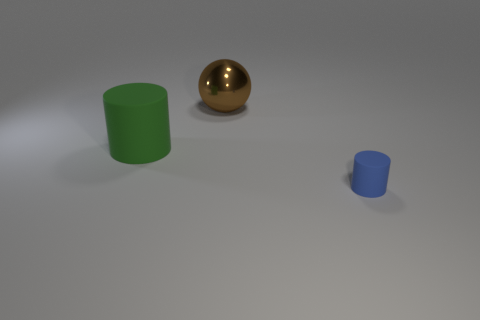There is a cylinder that is in front of the rubber cylinder behind the tiny blue object; what is it made of?
Your answer should be very brief. Rubber. Is the material of the thing that is behind the large rubber thing the same as the small thing?
Your answer should be compact. No. What is the cylinder that is behind the small blue rubber thing made of?
Provide a short and direct response. Rubber. Is there any other thing that has the same size as the blue rubber cylinder?
Offer a terse response. No. There is a blue cylinder; are there any rubber things behind it?
Provide a short and direct response. Yes. What number of big things are the same shape as the small object?
Your answer should be very brief. 1. There is a object that is behind the matte cylinder that is to the left of the small cylinder that is in front of the green thing; what color is it?
Provide a succinct answer. Brown. Does the large thing to the right of the large green thing have the same material as the green thing that is to the left of the small blue cylinder?
Your answer should be very brief. No. How many objects are either matte cylinders that are left of the small rubber cylinder or green cylinders?
Your response must be concise. 1. What number of things are either large green cylinders or rubber things right of the big green matte cylinder?
Ensure brevity in your answer.  2. 